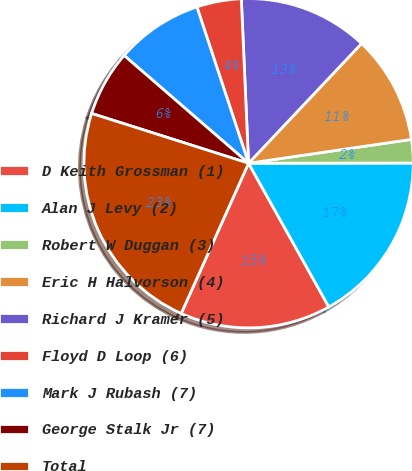Convert chart. <chart><loc_0><loc_0><loc_500><loc_500><pie_chart><fcel>D Keith Grossman (1)<fcel>Alan J Levy (2)<fcel>Robert W Duggan (3)<fcel>Eric H Halvorson (4)<fcel>Richard J Kramer (5)<fcel>Floyd D Loop (6)<fcel>Mark J Rubash (7)<fcel>George Stalk Jr (7)<fcel>Total<nl><fcel>14.82%<fcel>16.91%<fcel>2.29%<fcel>10.65%<fcel>12.74%<fcel>4.38%<fcel>8.56%<fcel>6.47%<fcel>23.18%<nl></chart> 